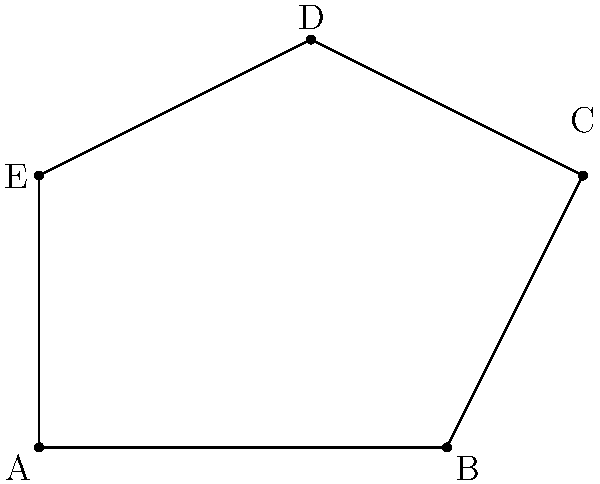A new protected wildlife habitat has been established with an irregular shape. The habitat's boundary is represented by the points A(0,0), B(6,0), C(8,4), D(4,6), and E(0,4) on a coordinate system where each unit represents 1 km. Calculate the total area of this habitat in square kilometers. To find the area of this irregular shape, we can use the Shoelace formula (also known as the surveyor's formula). The steps are as follows:

1) The Shoelace formula for a polygon with vertices $(x_1, y_1), (x_2, y_2), ..., (x_n, y_n)$ is:

   Area = $\frac{1}{2}|(x_1y_2 + x_2y_3 + ... + x_ny_1) - (y_1x_2 + y_2x_3 + ... + y_nx_1)|$

2) In our case, we have:
   A(0,0), B(6,0), C(8,4), D(4,6), E(0,4)

3) Applying the formula:

   Area = $\frac{1}{2}|[(0 \cdot 0) + (6 \cdot 4) + (8 \cdot 6) + (4 \cdot 4) + (0 \cdot 0)] - [(0 \cdot 6) + (0 \cdot 8) + (4 \cdot 4) + (6 \cdot 0) + (4 \cdot 0)]|$

4) Simplifying:

   Area = $\frac{1}{2}|(0 + 24 + 48 + 16 + 0) - (0 + 0 + 16 + 0 + 0)|$
   
   Area = $\frac{1}{2}|88 - 16|$
   
   Area = $\frac{1}{2}(72)$
   
   Area = 36

5) Since each unit represents 1 km, the area is 36 square kilometers.
Answer: 36 square kilometers 